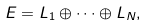Convert formula to latex. <formula><loc_0><loc_0><loc_500><loc_500>E = L _ { 1 } \oplus \cdots \oplus L _ { N } ,</formula> 